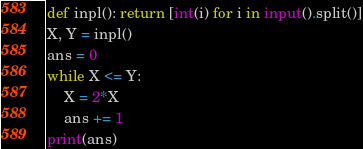<code> <loc_0><loc_0><loc_500><loc_500><_Python_>def inpl(): return [int(i) for i in input().split()]
X, Y = inpl()
ans = 0
while X <= Y:
    X = 2*X
    ans += 1
print(ans)</code> 